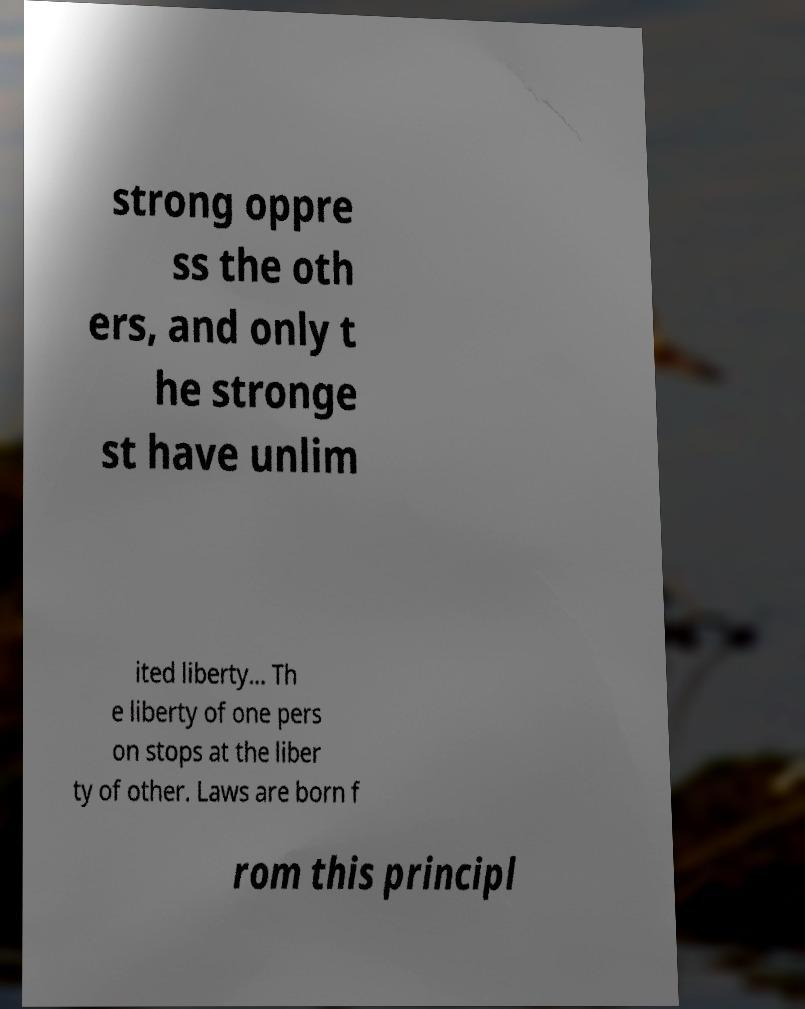Can you accurately transcribe the text from the provided image for me? strong oppre ss the oth ers, and only t he stronge st have unlim ited liberty... Th e liberty of one pers on stops at the liber ty of other. Laws are born f rom this principl 